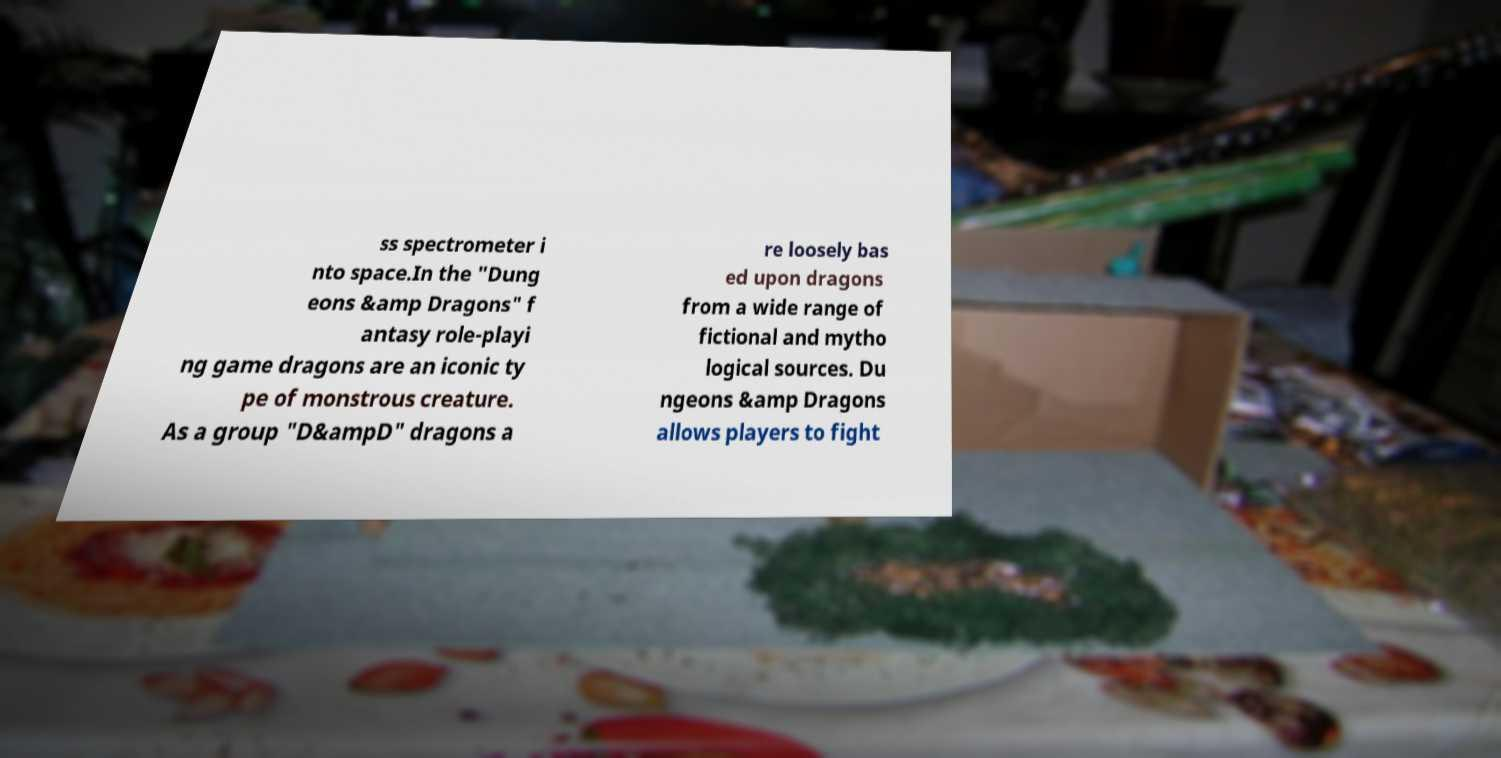There's text embedded in this image that I need extracted. Can you transcribe it verbatim? ss spectrometer i nto space.In the "Dung eons &amp Dragons" f antasy role-playi ng game dragons are an iconic ty pe of monstrous creature. As a group "D&ampD" dragons a re loosely bas ed upon dragons from a wide range of fictional and mytho logical sources. Du ngeons &amp Dragons allows players to fight 